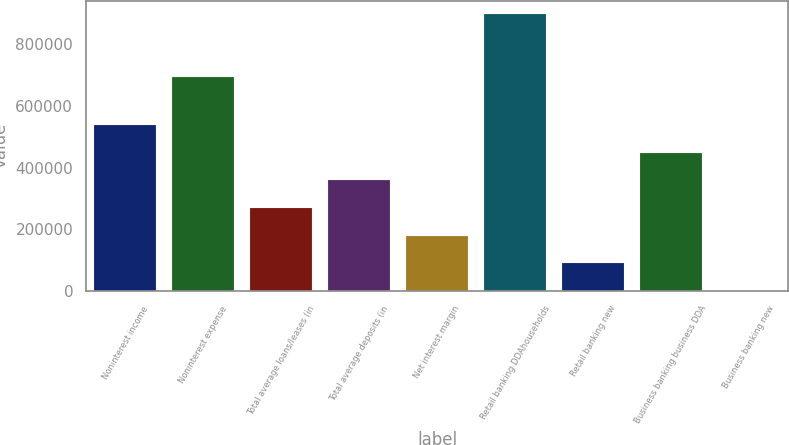<chart> <loc_0><loc_0><loc_500><loc_500><bar_chart><fcel>Noninterest income<fcel>Noninterest expense<fcel>Total average loans/leases (in<fcel>Total average deposits (in<fcel>Net interest margin<fcel>Retail banking DDAhouseholds<fcel>Retail banking new<fcel>Business banking business DDA<fcel>Business banking new<nl><fcel>537941<fcel>694942<fcel>268972<fcel>358628<fcel>179315<fcel>896567<fcel>89658.7<fcel>448285<fcel>2.27<nl></chart> 